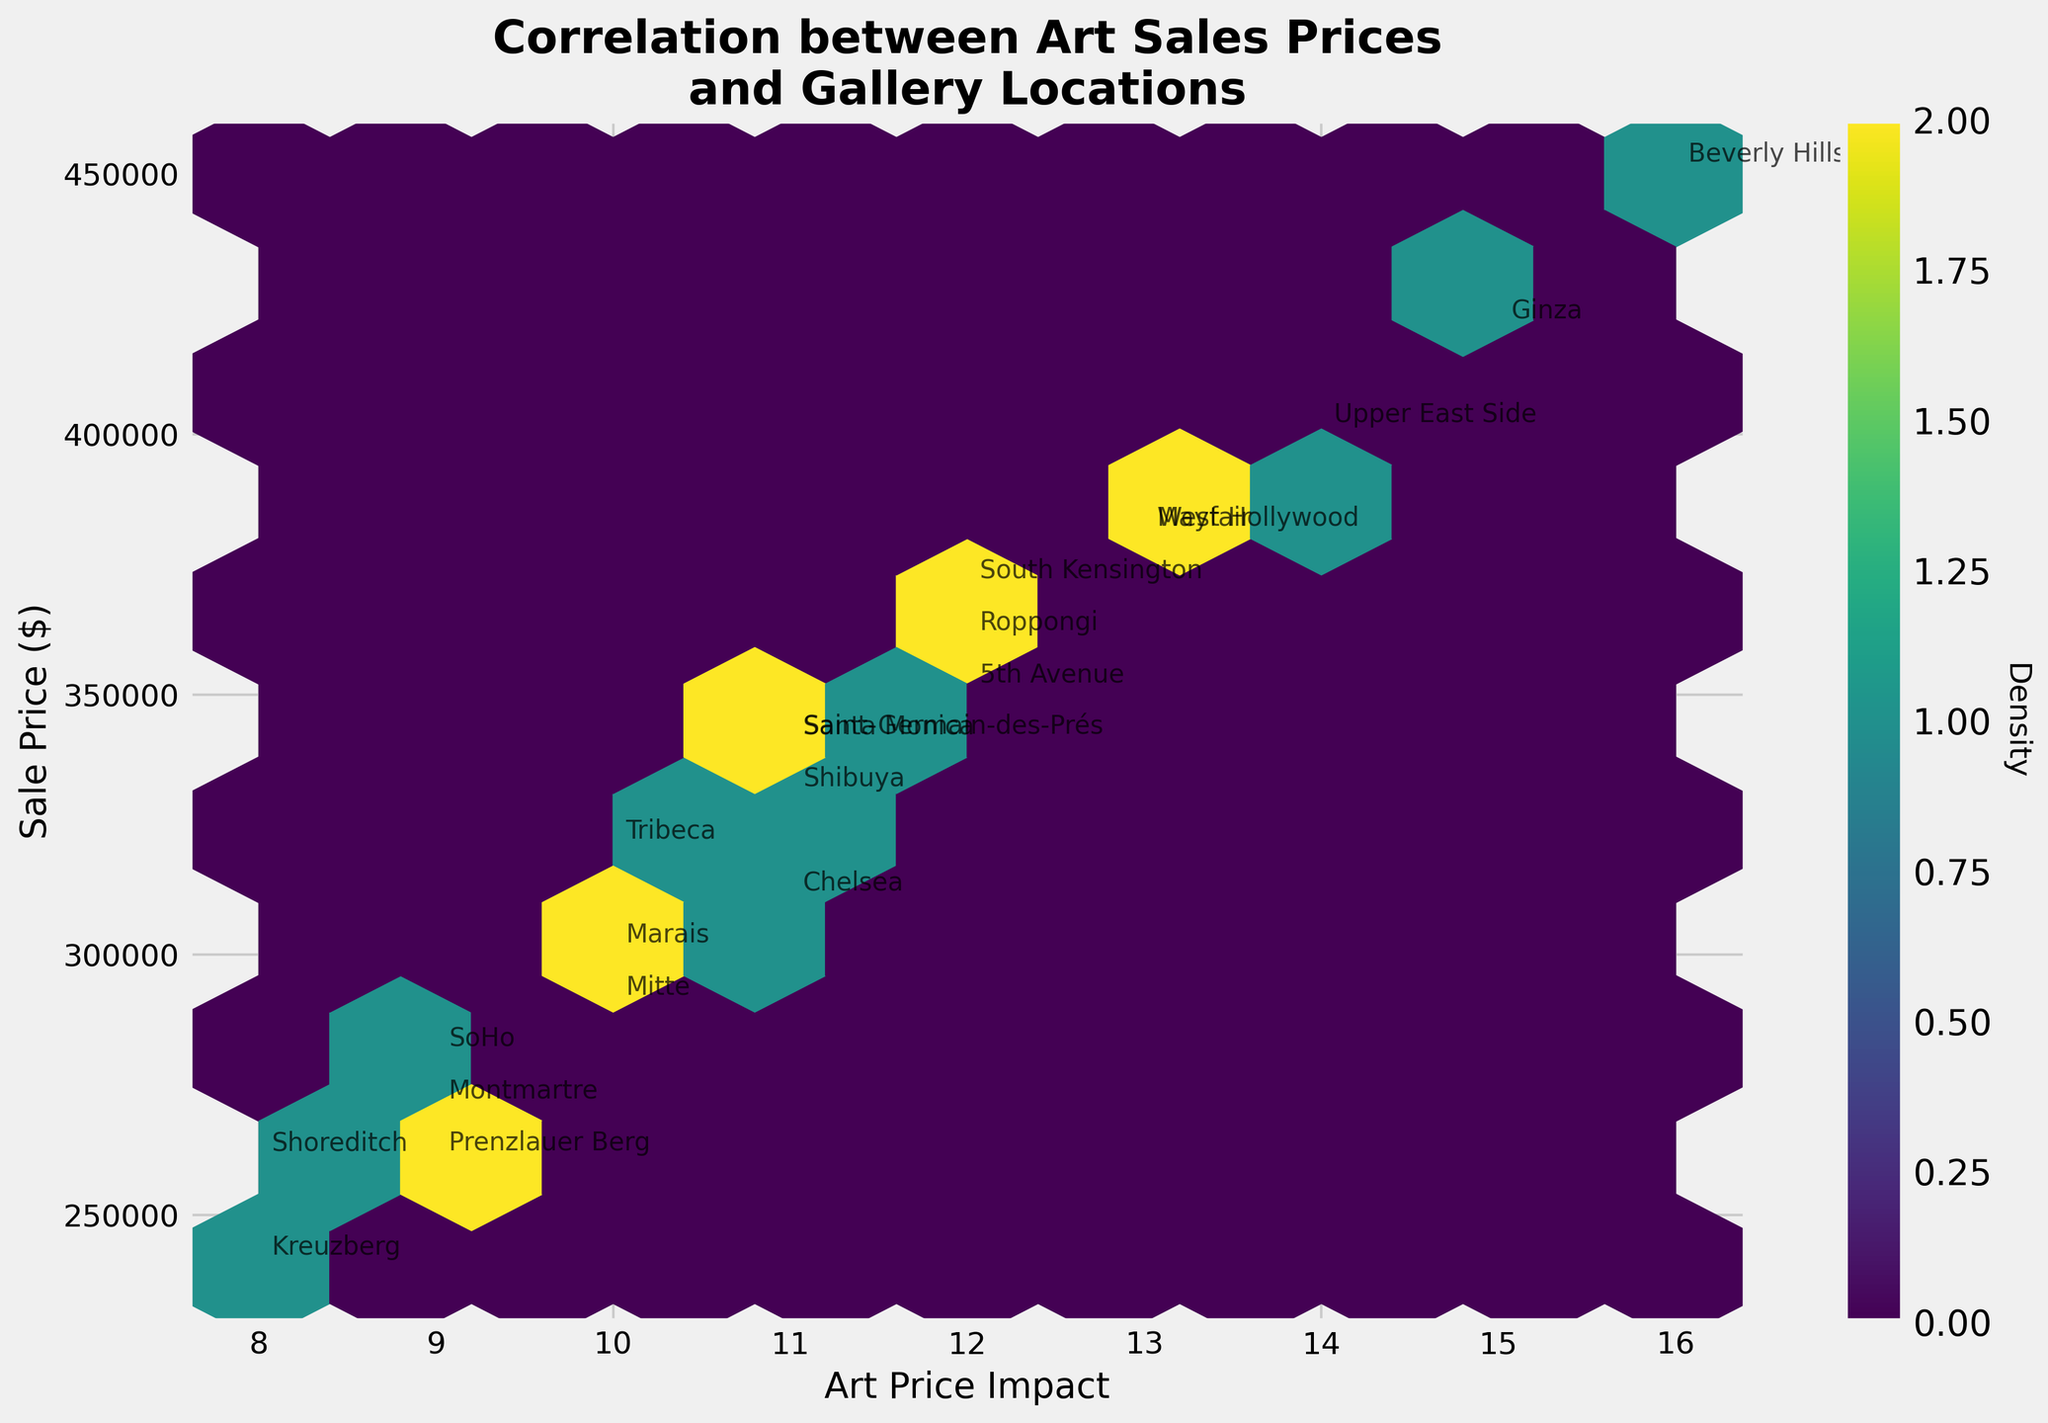What's the title of the plot? Look at the top of the plot to find the title, which summarizes the main visual information.
Answer: Correlation between Art Sales Prices and Gallery Locations What are the axes labels? The axes labels are usually found beside the axes lines and indicate what each axis represents.
Answer: Art Price Impact (X), Sale Price ($) (Y) Which location has the highest sale price? Find the data point with the highest value on the Y-axis and identify the associated label from the annotations.
Answer: Beverly Hills What's the range of sale prices shown on the plot? Examine the Y-axis labeling from the lowest to the highest numbers presented.
Answer: $240,000 to $450,000 Among the locations, which has a sale price closest to $300,000? Look for the value nearest to $300,000 on the Y-axis and check the label near that data point.
Answer: Marais How many data points are located within the highest density region in the hexbin plot? Locate the region with the densest hexagons (usually with the darkest color) and identify the approximate number of points within that region based on density.
Answer: Can't be determined exactly without the density scale, but approximated from the color bar. Likely contains multiple data points Which two locations have the sale price difference of $50,000? Identify pairs of labels on the Y-axis whose difference amounts to $50,000.
Answer: 5th Avenue and Tribeca What do the colors in the hexbin plot represent? The colors in a hexabin plot typically show the density of the data points within each bin, relating to the color bar.
Answer: Density Which hexbin color indicates a higher density of data points? Reference the color bar to see which color corresponds to a higher density value.
Answer: Darkest color (likely near purple/black on the 'viridis' scale) 